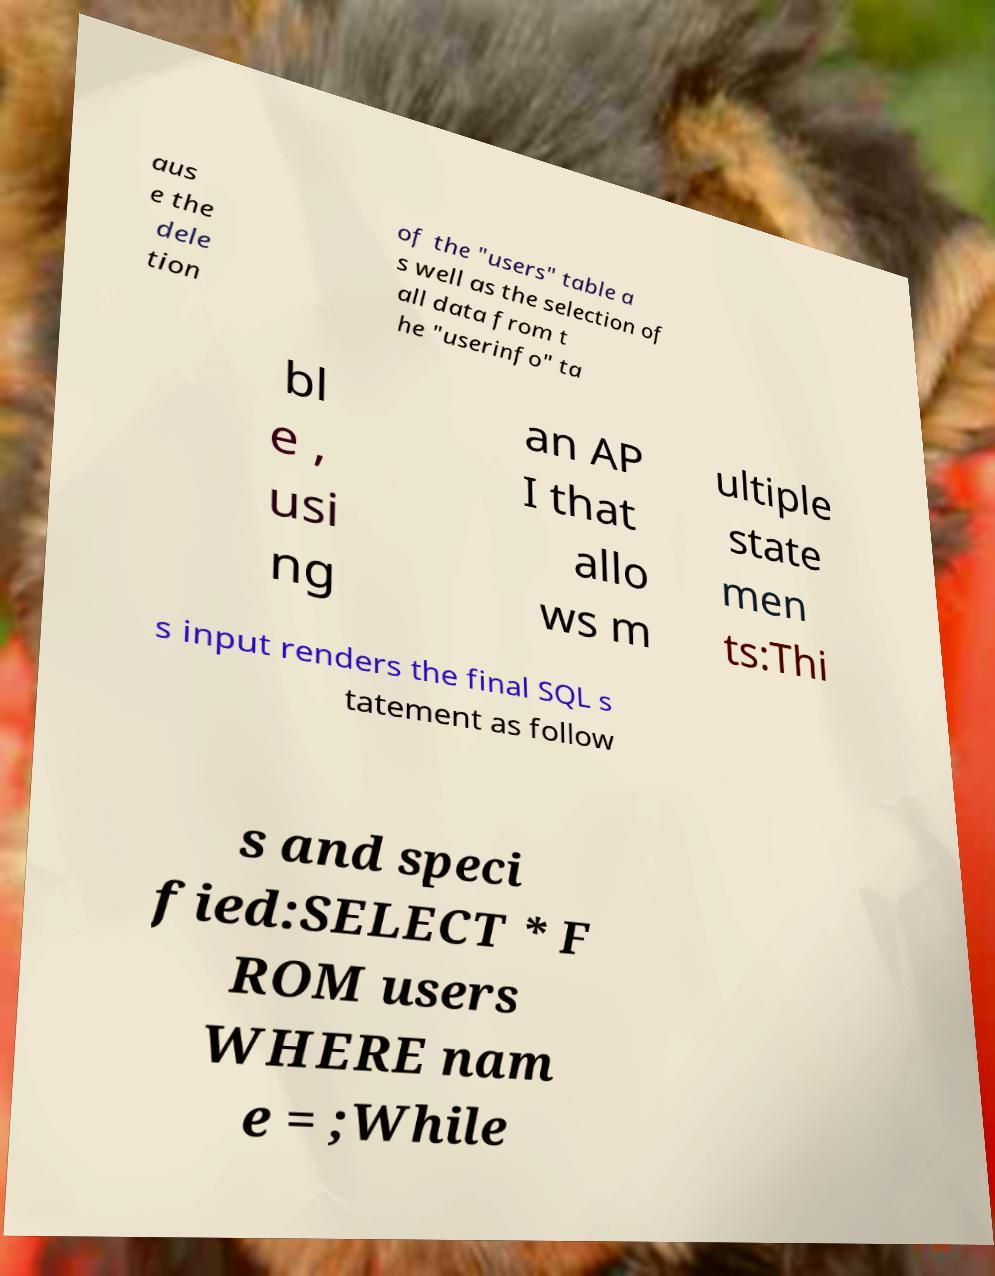There's text embedded in this image that I need extracted. Can you transcribe it verbatim? aus e the dele tion of the "users" table a s well as the selection of all data from t he "userinfo" ta bl e , usi ng an AP I that allo ws m ultiple state men ts:Thi s input renders the final SQL s tatement as follow s and speci fied:SELECT * F ROM users WHERE nam e = ;While 